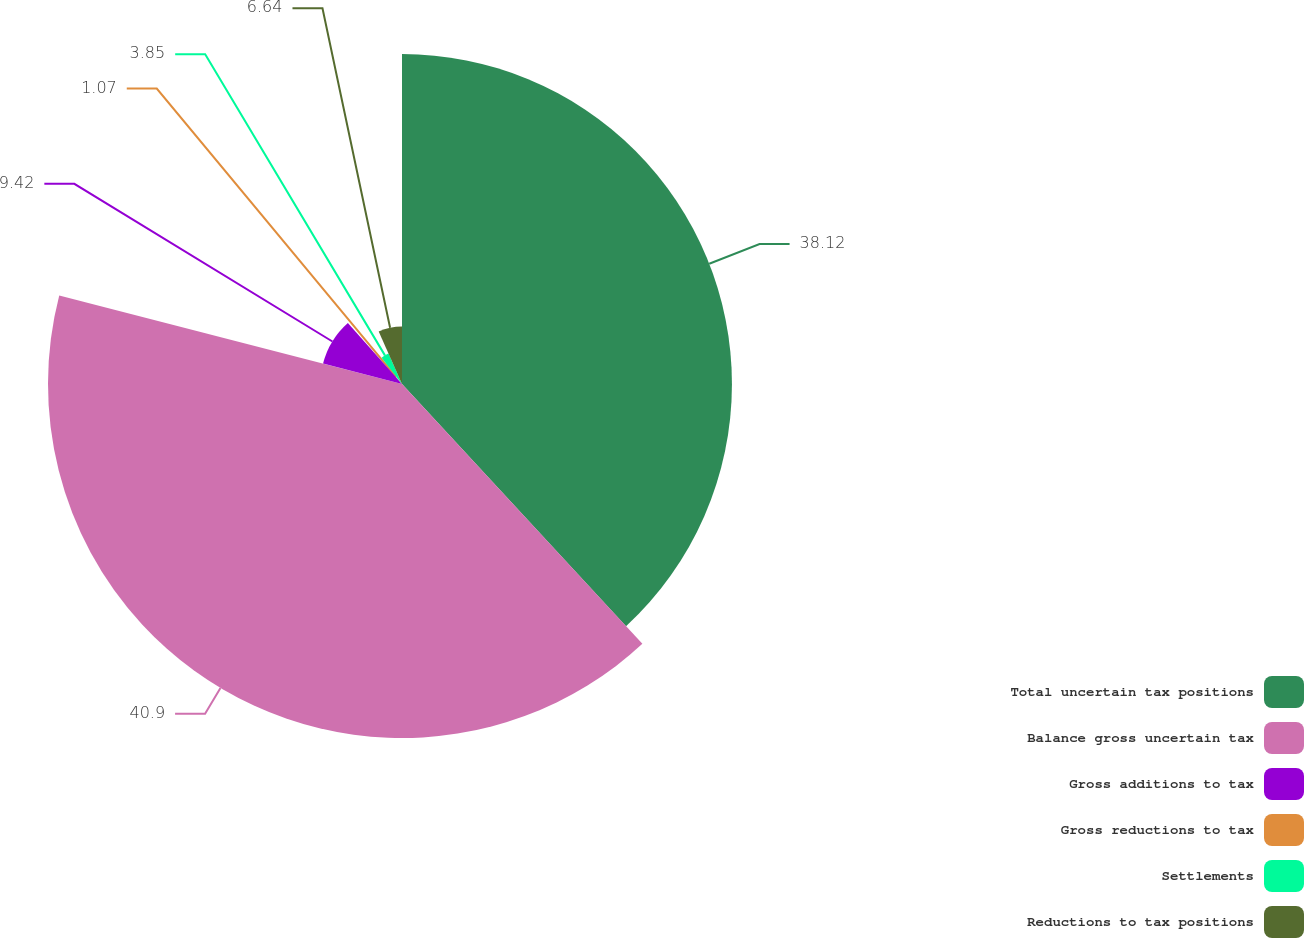<chart> <loc_0><loc_0><loc_500><loc_500><pie_chart><fcel>Total uncertain tax positions<fcel>Balance gross uncertain tax<fcel>Gross additions to tax<fcel>Gross reductions to tax<fcel>Settlements<fcel>Reductions to tax positions<nl><fcel>38.12%<fcel>40.9%<fcel>9.42%<fcel>1.07%<fcel>3.85%<fcel>6.64%<nl></chart> 